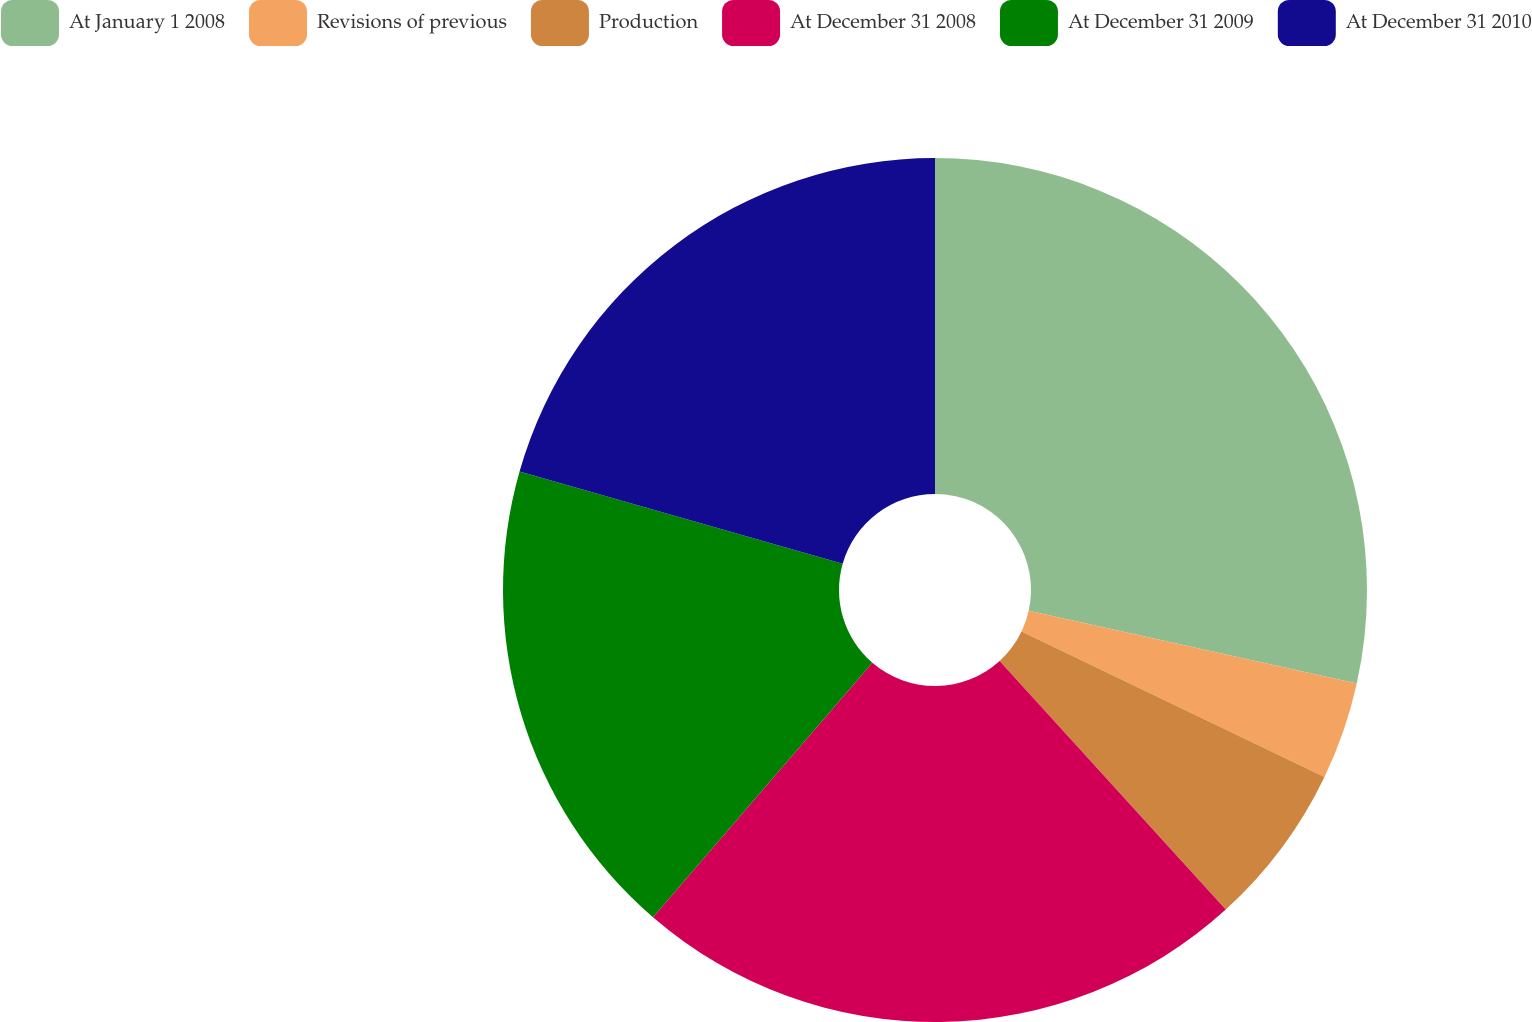<chart> <loc_0><loc_0><loc_500><loc_500><pie_chart><fcel>At January 1 2008<fcel>Revisions of previous<fcel>Production<fcel>At December 31 2008<fcel>At December 31 2009<fcel>At December 31 2010<nl><fcel>28.47%<fcel>3.65%<fcel>6.13%<fcel>23.07%<fcel>18.1%<fcel>20.58%<nl></chart> 